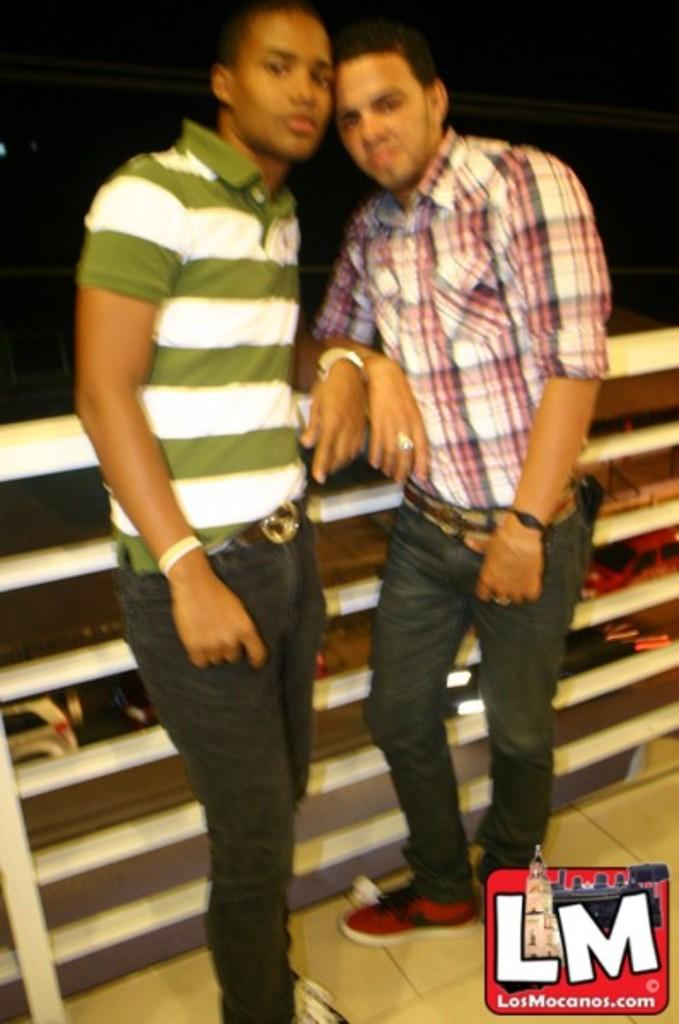How many people are in the image? There are two men standing in the image. What can be found in the bottom right corner of the image? The bottom right of the image contains a logo. What is the color of the background in the image? The background of the image is dark. What type of objects can be seen on the surface in the image? There are vehicles visible on the surface in the image. What type of temper does the wrench have in the image? There is no wrench present in the image, so it is not possible to determine its temper. 